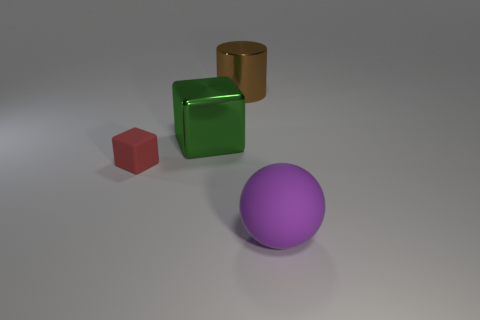What is the size of the block that is in front of the cube that is right of the rubber object to the left of the green shiny block?
Provide a short and direct response. Small. Do the small object and the object in front of the tiny thing have the same material?
Offer a terse response. Yes. There is another purple object that is the same material as the small thing; what size is it?
Offer a very short reply. Large. Are there any gray shiny objects that have the same shape as the small red rubber object?
Give a very brief answer. No. What number of things are either matte things that are right of the red rubber thing or big spheres?
Offer a very short reply. 1. Is the color of the rubber object to the left of the large purple object the same as the large thing that is to the right of the cylinder?
Offer a terse response. No. What is the size of the metal cube?
Your response must be concise. Large. What number of big objects are either green metallic objects or brown objects?
Your answer should be very brief. 2. What color is the cylinder that is the same size as the green metal block?
Offer a terse response. Brown. How many other objects are there of the same shape as the purple object?
Provide a short and direct response. 0. 